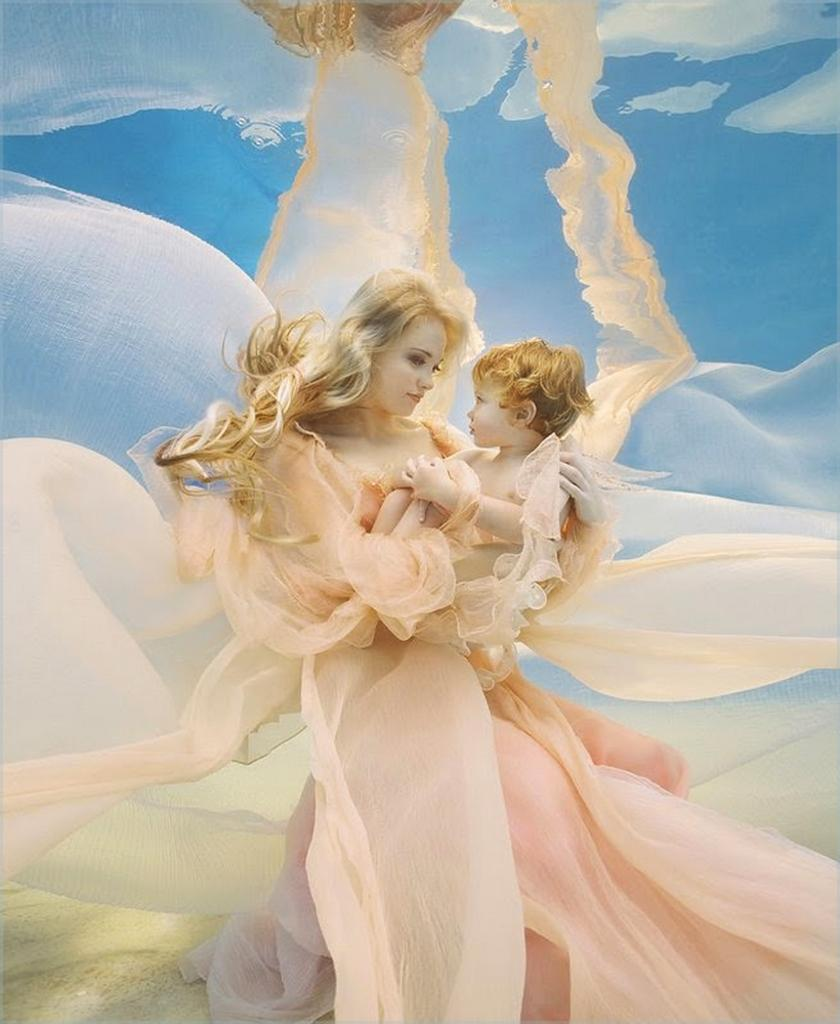What is the lady in the image holding? The lady is holding a baby in the image. What type of surface is at the bottom of the image? There is sand at the bottom of the image. What can be seen in the background of the image? The sky is visible in the background of the image. What color is the tail of the kite in the image? There is no kite present in the image, so there is no tail to describe. 